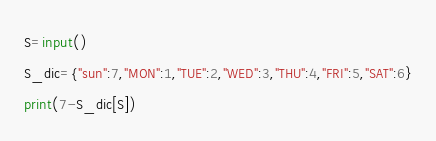<code> <loc_0><loc_0><loc_500><loc_500><_Python_>S=input()
S_dic={"sun":7,"MON":1,"TUE":2,"WED":3,"THU":4,"FRI":5,"SAT":6}
print(7-S_dic[S])</code> 